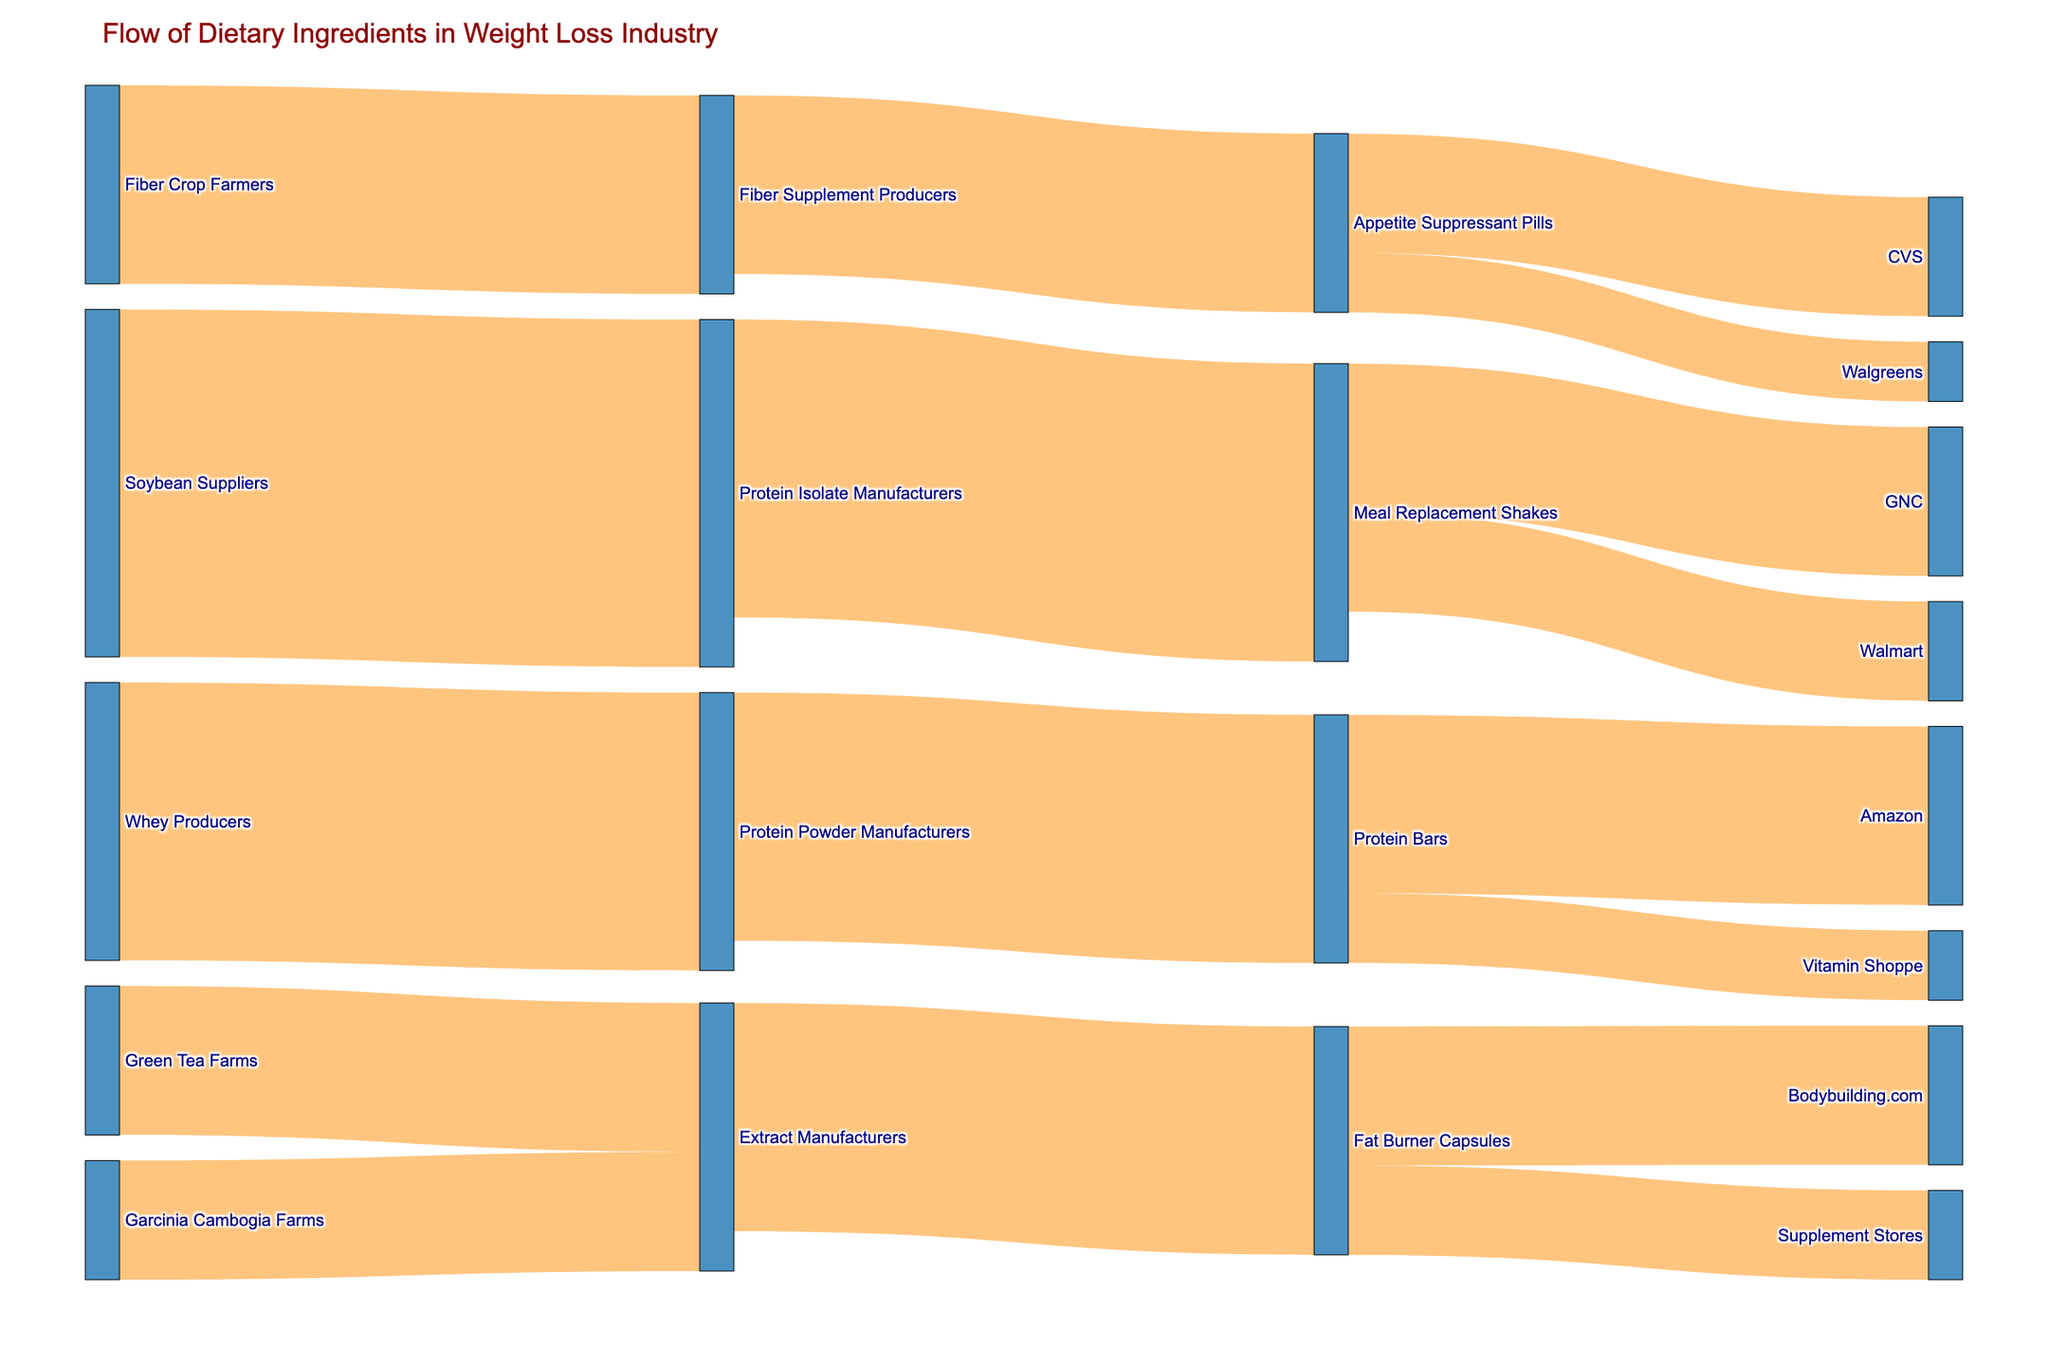What is the title of the figure? The title is located at the top of the figure and clearly states what the figure represents.
Answer: Flow of Dietary Ingredients in Weight Loss Industry Which ingredient has the highest initial value from suppliers? The widest link in the figure from the suppliers to manufacturers will indicate the highest initial value. Soybean Suppliers to Protein Isolate Manufacturers has the highest value of 350.
Answer: Soybean Suppliers What is the total value of dietary ingredients supplied from Protein Isolate Manufacturers? Sum the values of all flows originating from Protein Isolate Manufacturers to their respective targets. These flows are: Meal Replacement Shakes (300). 300.
Answer: 300 Which retail outlet receives the most Meal Replacement Shakes? Compare the values of links flowing from Meal Replacement Shakes to GNC and Walmart. GNC receives 150 and Walmart receives 100.
Answer: GNC What is the combined value of products received by CVS and Walgreens? Add the values of links from Appetite Suppressant Pills to CVS and Walgreens. CVS receives 120 and Walgreens receives 60. The combined value is 180.
Answer: 180 Which product flows into the most end products? Count the number of end products for each product. Protein Bars flow into Amazon and Vitamin Shoppe (2). Meal Replacement Shakes flow into GNC and Walmart (2). Comparison shows an equal flow into end products but more uniquely placed value goes to Protein Bars.
Answer: Protein Bars How many distinct suppliers are there? Count the unique suppliers listed under the source column. The distinct suppliers are Soybean Suppliers, Whey Producers, Fiber Crop Farmers, Green Tea Farms, Garcinia Cambogia Farms (5 suppliers).
Answer: 5 Does Walmart receive more Meal Replacement Shakes or CVS receive more Appetite Suppressant Pills? Compare the values of links from Meal Replacement Shakes to Walmart (100) and from Appetite Suppressant Pills to CVS (120). 120 is greater than 100.
Answer: CVS Which manufacturer receives the least supply from ingredient suppliers? Compare the values of links from suppliers to manufacturers. Garcinia Cambogia Farms to Extract Manufacturers (120) is the smallest value.
Answer: Extract Manufacturers What is the value of products ending at Vitamin Shoppe and how does it compare to Amazon? Compare the values of links from manufacturers/products to Vitamin Shoppe and Amazon. Vitamin Shoppe gets 70 from Protein Bars. Amazon gets 180 from Protein Bars. 70 vs 180, Amazon receives more.
Answer: Amazon 